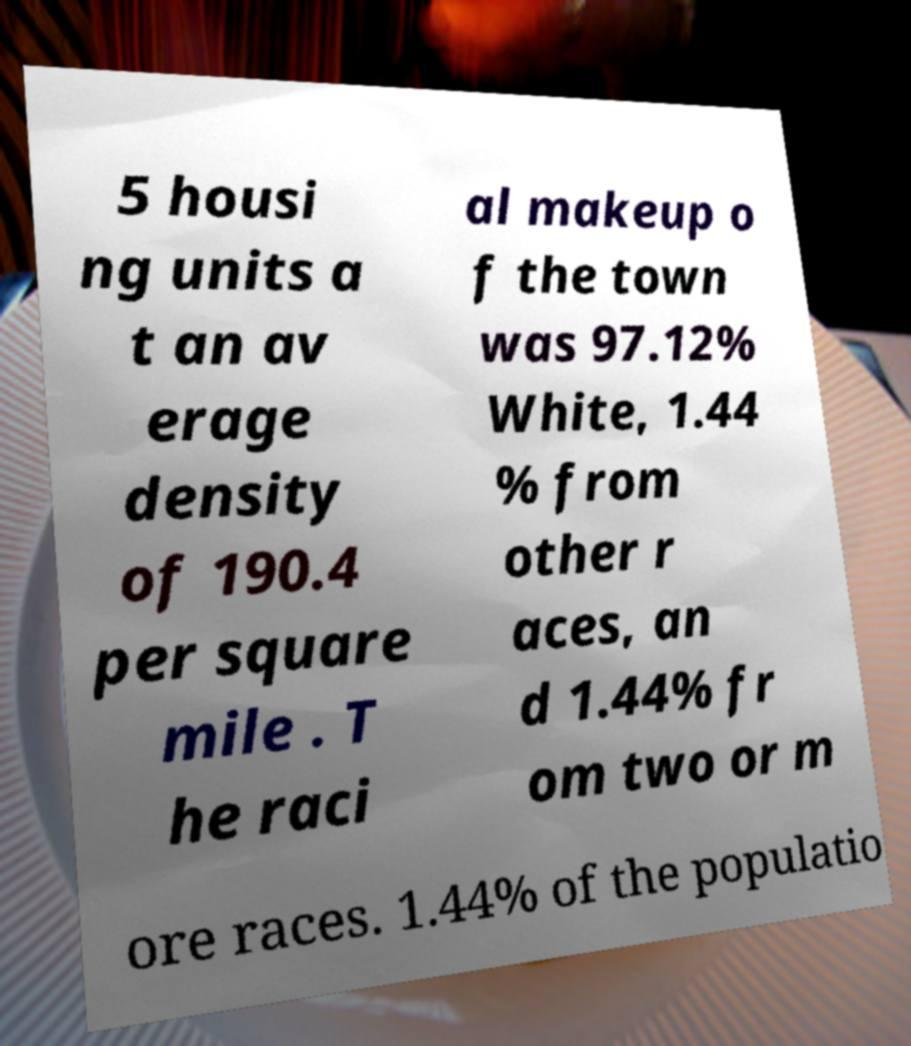Can you accurately transcribe the text from the provided image for me? 5 housi ng units a t an av erage density of 190.4 per square mile . T he raci al makeup o f the town was 97.12% White, 1.44 % from other r aces, an d 1.44% fr om two or m ore races. 1.44% of the populatio 